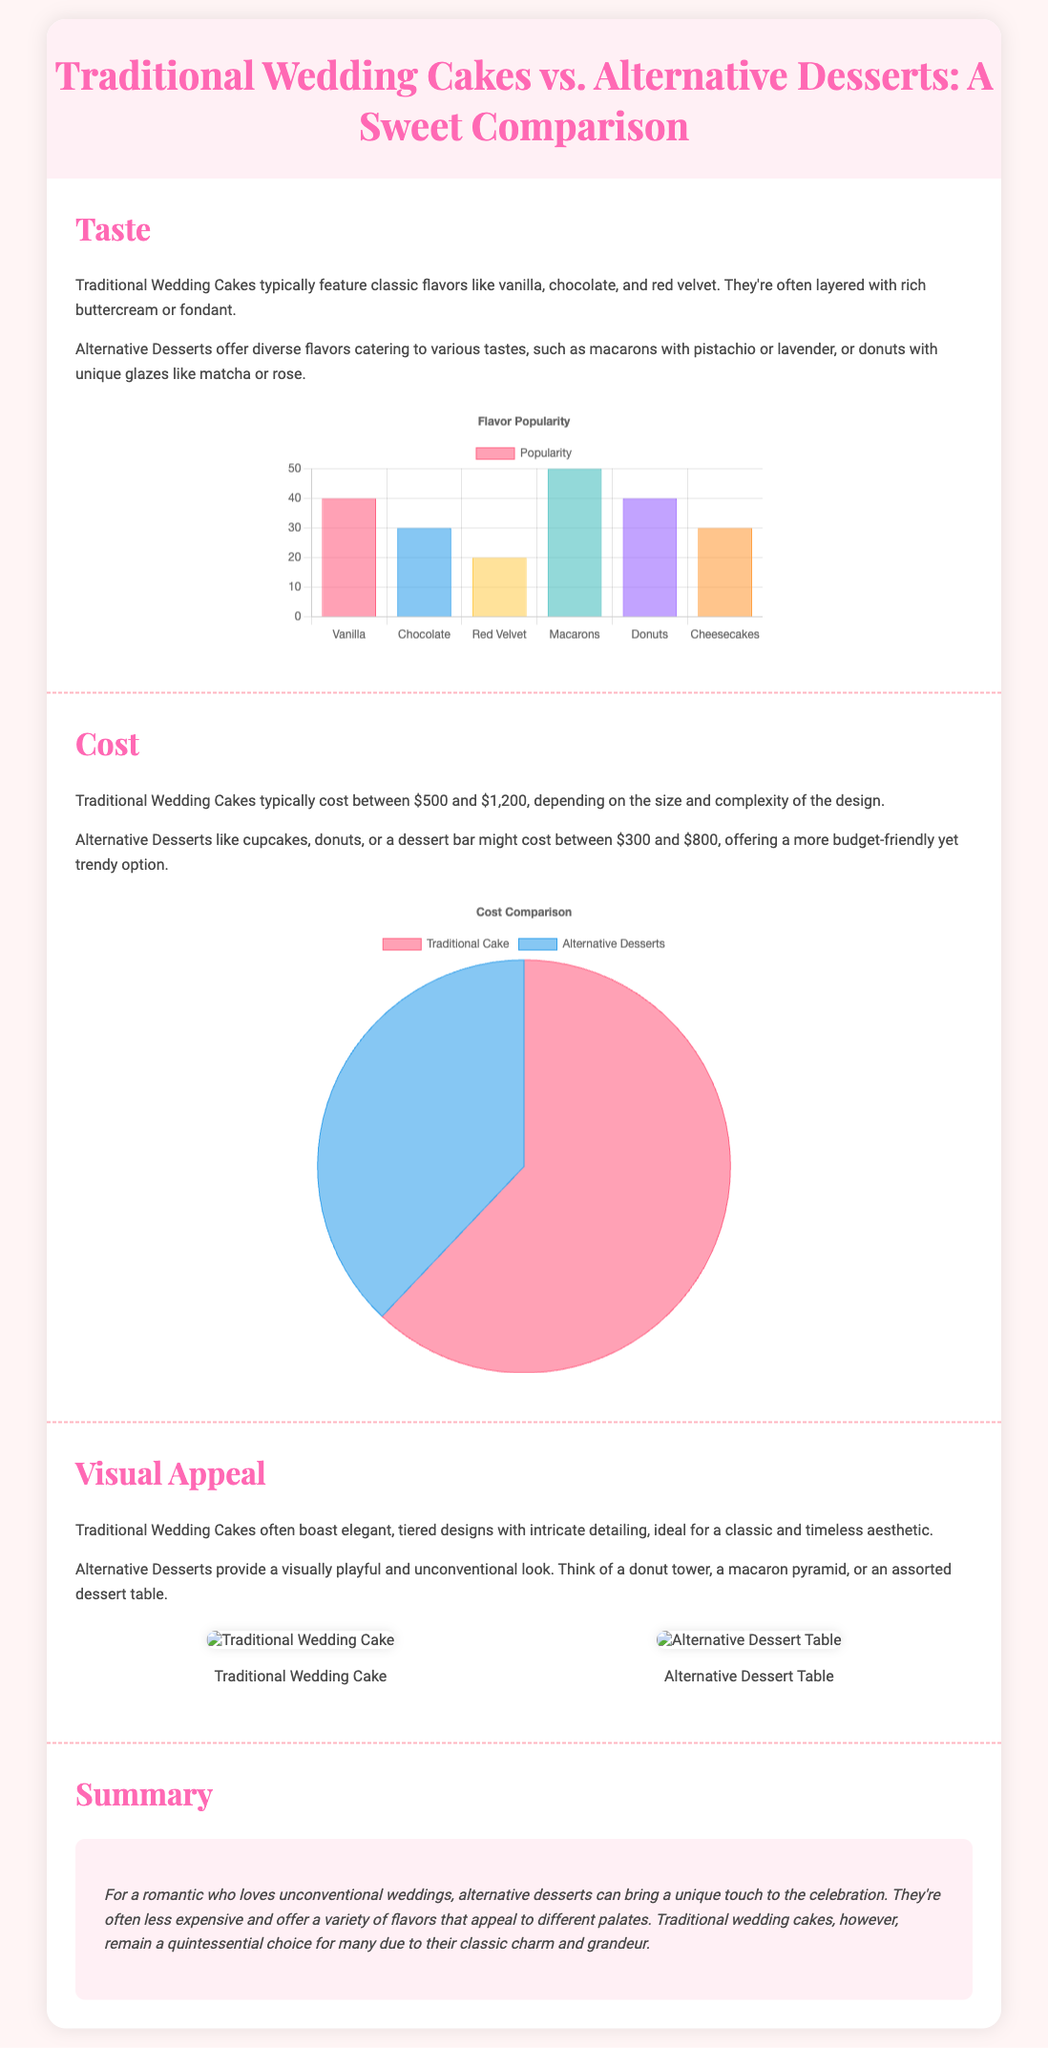What are the classic flavors typically found in Traditional Wedding Cakes? Traditional Wedding Cakes feature classic flavors like vanilla, chocolate, and red velvet.
Answer: Vanilla, chocolate, red velvet What is the cost range for Alternative Desserts? Alternative Desserts like cupcakes, donuts, or a dessert bar might cost between $300 and $800.
Answer: $300 to $800 Which dessert has a popularity value of 50? Macarons have a popularity value of 50 as indicated in the flavor popularity chart.
Answer: Macarons What is a unique visual feature of Alternative Desserts? Alternative Desserts provide a visually playful and unconventional look, such as a donut tower or a macaron pyramid.
Answer: Visually playful, unconventional look What is the average cost of Traditional Wedding Cakes based on the document? Traditional Wedding Cakes typically cost between $500 and $1,200, with an average of around $900.
Answer: $900 